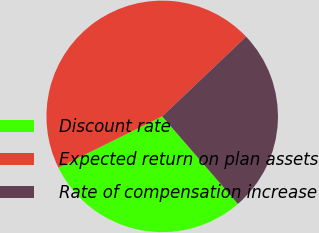<chart> <loc_0><loc_0><loc_500><loc_500><pie_chart><fcel>Discount rate<fcel>Expected return on plan assets<fcel>Rate of compensation increase<nl><fcel>29.04%<fcel>45.22%<fcel>25.74%<nl></chart> 